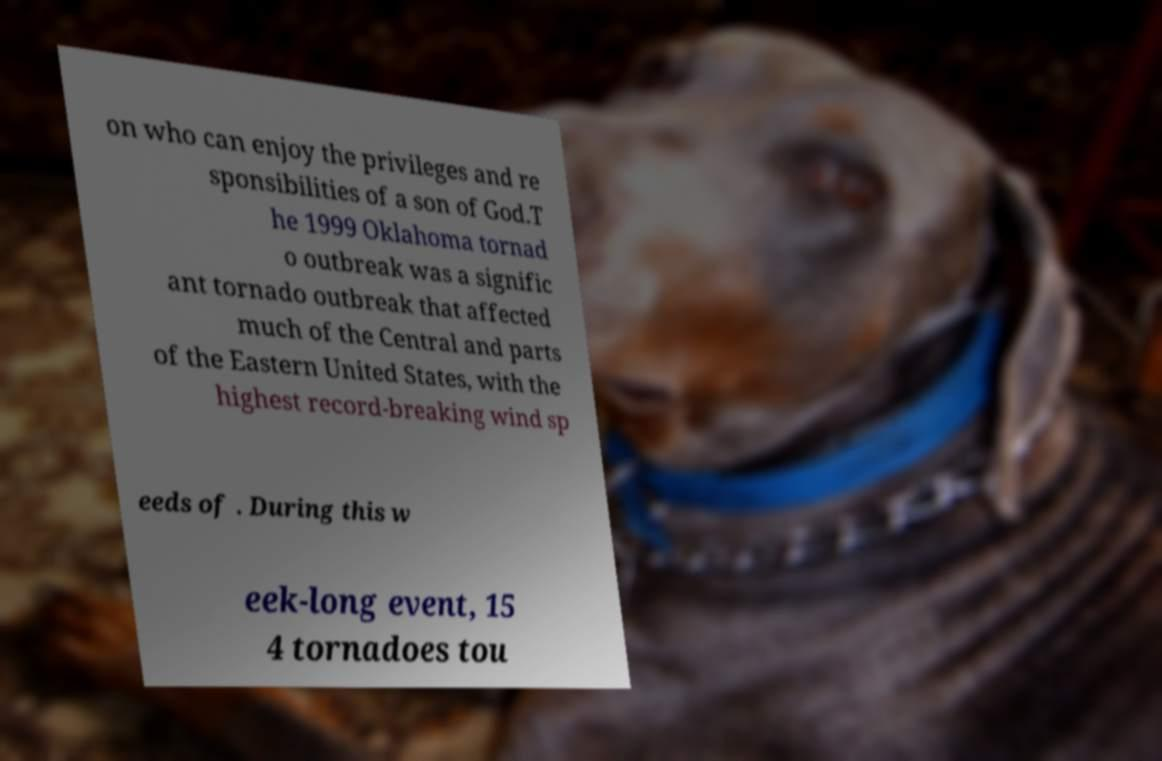I need the written content from this picture converted into text. Can you do that? on who can enjoy the privileges and re sponsibilities of a son of God.T he 1999 Oklahoma tornad o outbreak was a signific ant tornado outbreak that affected much of the Central and parts of the Eastern United States, with the highest record-breaking wind sp eeds of . During this w eek-long event, 15 4 tornadoes tou 